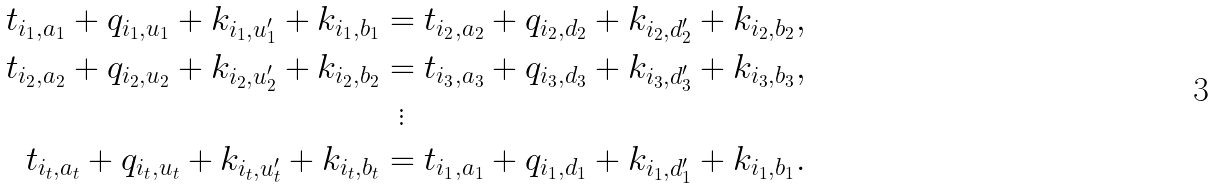Convert formula to latex. <formula><loc_0><loc_0><loc_500><loc_500>t _ { i _ { 1 } , a _ { 1 } } + q _ { i _ { 1 } , u _ { 1 } } + k _ { i _ { 1 } , u _ { 1 } ^ { \prime } } + k _ { i _ { 1 } , b _ { 1 } } & = t _ { i _ { 2 } , a _ { 2 } } + q _ { i _ { 2 } , d _ { 2 } } + k _ { i _ { 2 } , d _ { 2 } ^ { \prime } } + k _ { i _ { 2 } , b _ { 2 } } , \\ t _ { i _ { 2 } , a _ { 2 } } + q _ { i _ { 2 } , u _ { 2 } } + k _ { i _ { 2 } , u _ { 2 } ^ { \prime } } + k _ { i _ { 2 } , b _ { 2 } } & = t _ { i _ { 3 } , a _ { 3 } } + q _ { i _ { 3 } , d _ { 3 } } + k _ { i _ { 3 } , d _ { 3 } ^ { \prime } } + k _ { i _ { 3 } , b _ { 3 } } , \\ & \ \, \vdots \\ t _ { i _ { t } , a _ { t } } + q _ { i _ { t } , u _ { t } } + k _ { i _ { t } , u _ { t } ^ { \prime } } + k _ { i _ { t } , b _ { t } } & = t _ { i _ { 1 } , a _ { 1 } } + q _ { i _ { 1 } , d _ { 1 } } + k _ { i _ { 1 } , d _ { 1 } ^ { \prime } } + k _ { i _ { 1 } , b _ { 1 } } .</formula> 